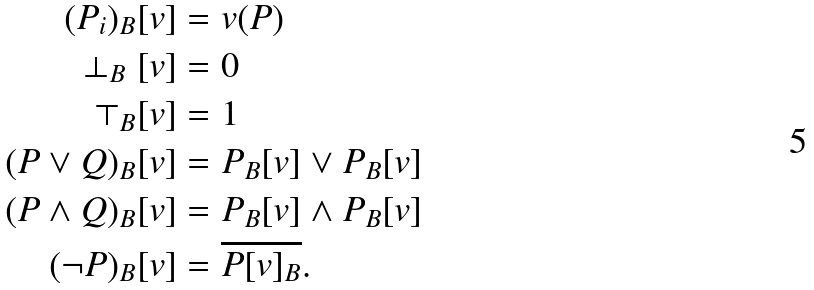<formula> <loc_0><loc_0><loc_500><loc_500>( P _ { i } ) _ { B } [ v ] & = v ( P ) \\ \perp _ { B } [ v ] & = 0 \\ \top _ { B } [ v ] & = 1 \\ ( P \lor Q ) _ { B } [ v ] & = P _ { B } [ v ] \lor P _ { B } [ v ] \\ ( P \land Q ) _ { B } [ v ] & = P _ { B } [ v ] \land P _ { B } [ v ] \\ ( \neg P ) _ { B } [ v ] & = \overline { P [ v ] _ { B } } .</formula> 